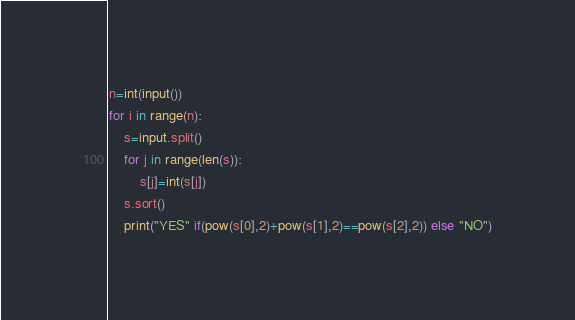Convert code to text. <code><loc_0><loc_0><loc_500><loc_500><_Python_>n=int(input())
for i in range(n):
	s=input.split()
	for j in range(len(s)):
		s[j]=int(s[j])
	s.sort()
	print("YES" if(pow(s[0],2)+pow(s[1],2)==pow(s[2],2)) else "NO")
</code> 